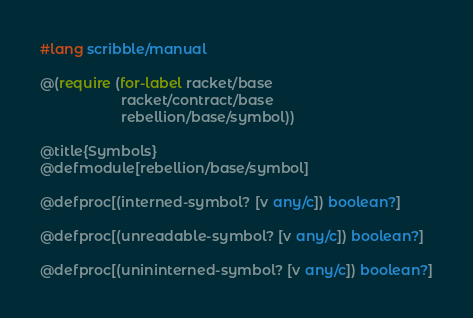<code> <loc_0><loc_0><loc_500><loc_500><_Racket_>#lang scribble/manual

@(require (for-label racket/base
                     racket/contract/base
                     rebellion/base/symbol))

@title{Symbols}
@defmodule[rebellion/base/symbol]

@defproc[(interned-symbol? [v any/c]) boolean?]

@defproc[(unreadable-symbol? [v any/c]) boolean?]

@defproc[(unininterned-symbol? [v any/c]) boolean?]
</code> 